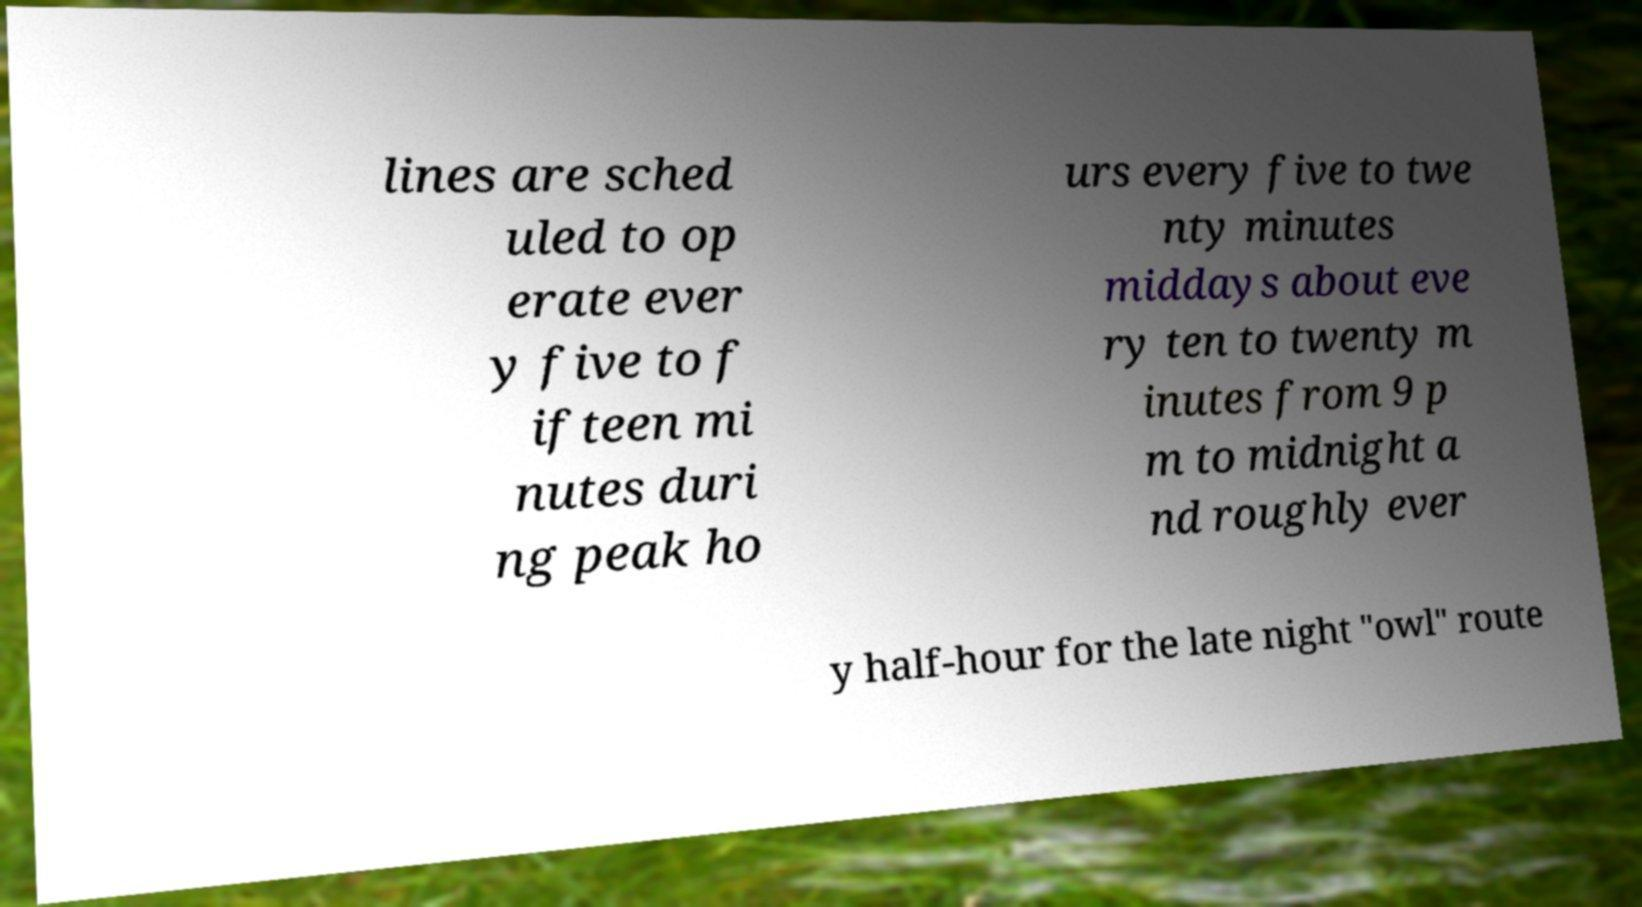Please identify and transcribe the text found in this image. lines are sched uled to op erate ever y five to f ifteen mi nutes duri ng peak ho urs every five to twe nty minutes middays about eve ry ten to twenty m inutes from 9 p m to midnight a nd roughly ever y half-hour for the late night "owl" route 